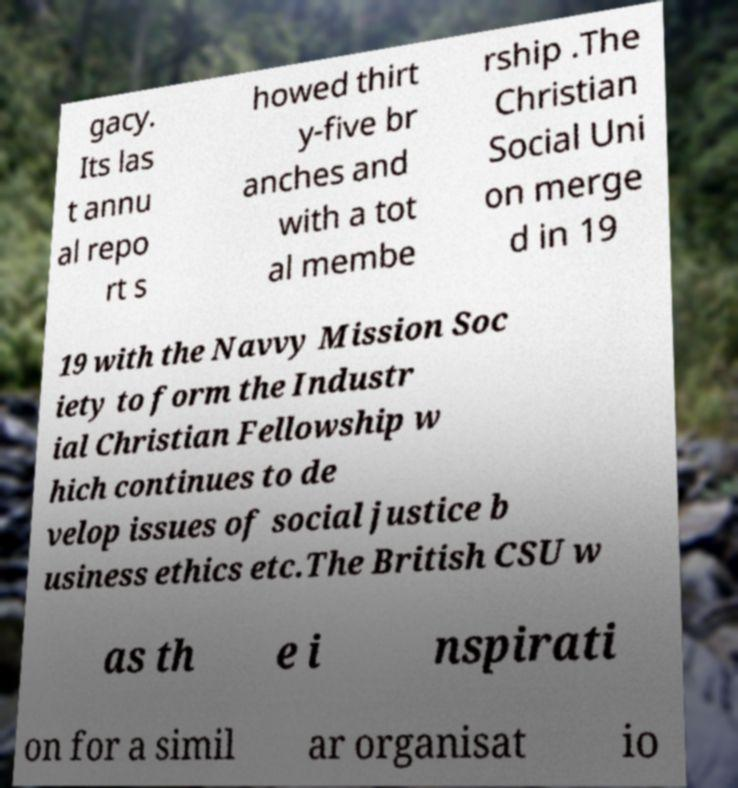Could you assist in decoding the text presented in this image and type it out clearly? gacy. Its las t annu al repo rt s howed thirt y-five br anches and with a tot al membe rship .The Christian Social Uni on merge d in 19 19 with the Navvy Mission Soc iety to form the Industr ial Christian Fellowship w hich continues to de velop issues of social justice b usiness ethics etc.The British CSU w as th e i nspirati on for a simil ar organisat io 